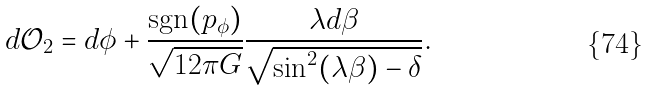Convert formula to latex. <formula><loc_0><loc_0><loc_500><loc_500>d \mathcal { O } _ { 2 } = d \phi + \frac { \text {sgn} ( p _ { \phi } ) } { \sqrt { 1 2 \pi G } } \frac { \lambda d \beta } { \sqrt { \sin ^ { 2 } ( \lambda \beta ) - \delta } } .</formula> 